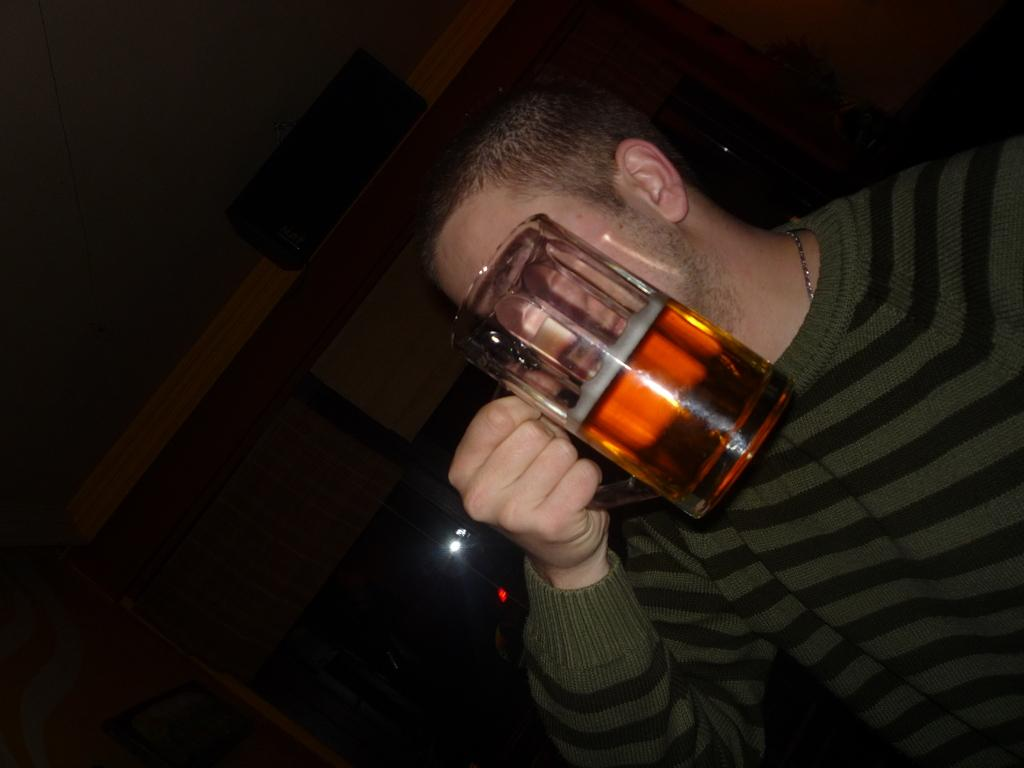What is the main subject of the image? There is a person in the image. What is the person holding in the image? The person is holding a glass. Can you describe the person's clothing in the image? The person is wearing a green and black color shirt. What can be seen in the background of the image? The background of the image is dark. What type of transport is the person using in the image? There is no transport visible in the image; it only features a person holding a glass. Can you tell me who the manager is in the image? There is no manager mentioned or depicted in the image. 